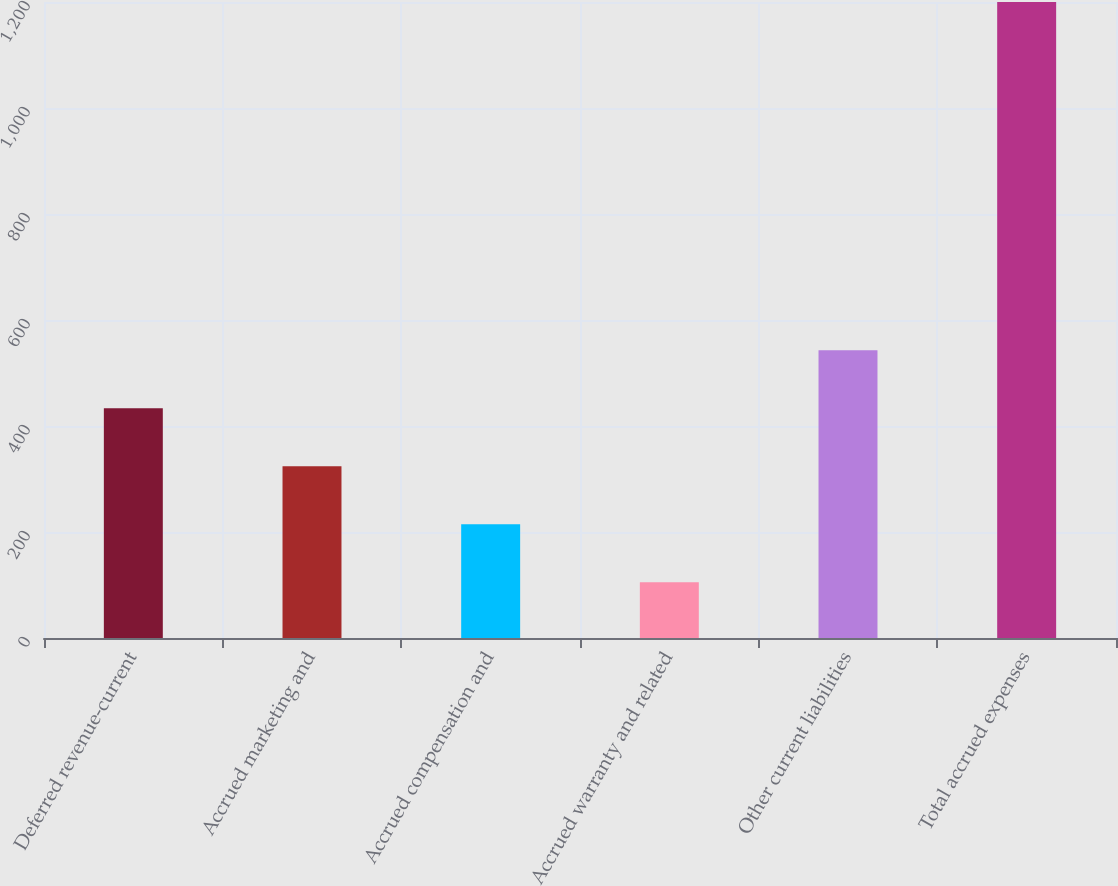Convert chart. <chart><loc_0><loc_0><loc_500><loc_500><bar_chart><fcel>Deferred revenue-current<fcel>Accrued marketing and<fcel>Accrued compensation and<fcel>Accrued warranty and related<fcel>Other current liabilities<fcel>Total accrued expenses<nl><fcel>433.5<fcel>324<fcel>214.5<fcel>105<fcel>543<fcel>1200<nl></chart> 